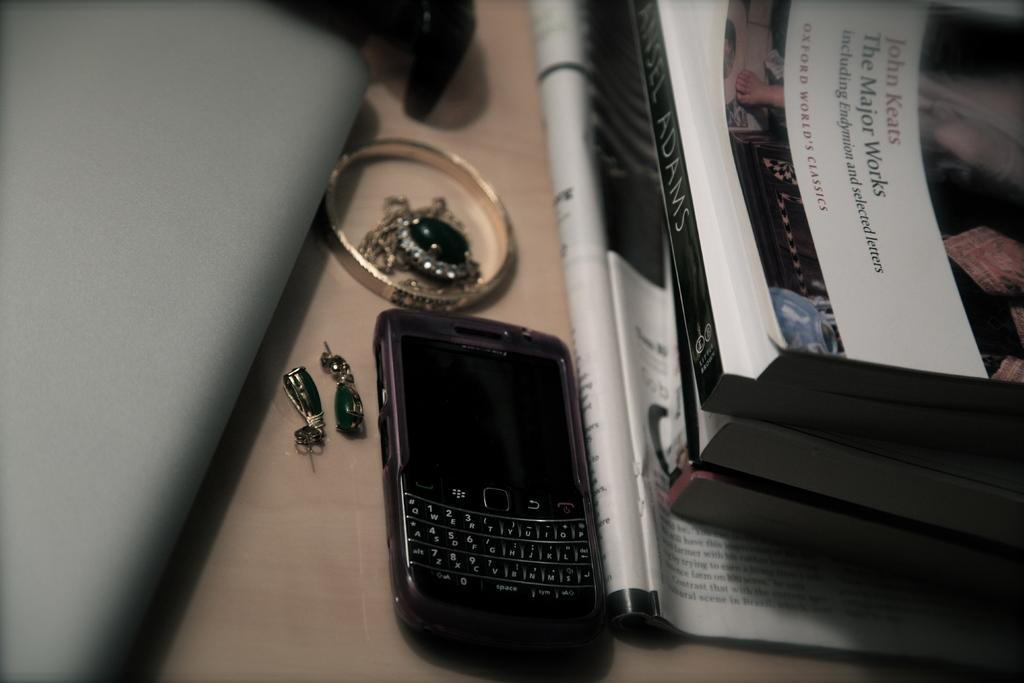<image>
Render a clear and concise summary of the photo. Some items on a table along with a book titled "John Keats: The Major Works" 